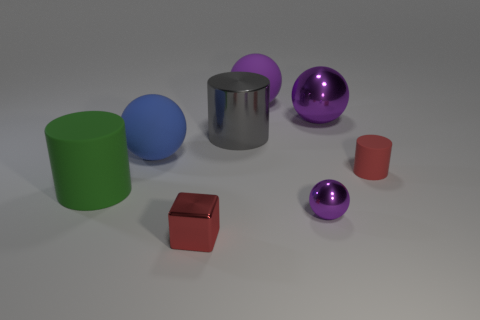Subtract all green blocks. How many purple spheres are left? 3 Add 2 red matte cylinders. How many objects exist? 10 Subtract all blocks. How many objects are left? 7 Add 4 large purple rubber objects. How many large purple rubber objects exist? 5 Subtract 0 purple blocks. How many objects are left? 8 Subtract all cyan cylinders. Subtract all red objects. How many objects are left? 6 Add 3 red things. How many red things are left? 5 